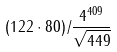<formula> <loc_0><loc_0><loc_500><loc_500>( 1 2 2 \cdot 8 0 ) / \frac { 4 ^ { 4 0 9 } } { \sqrt { 4 4 9 } }</formula> 